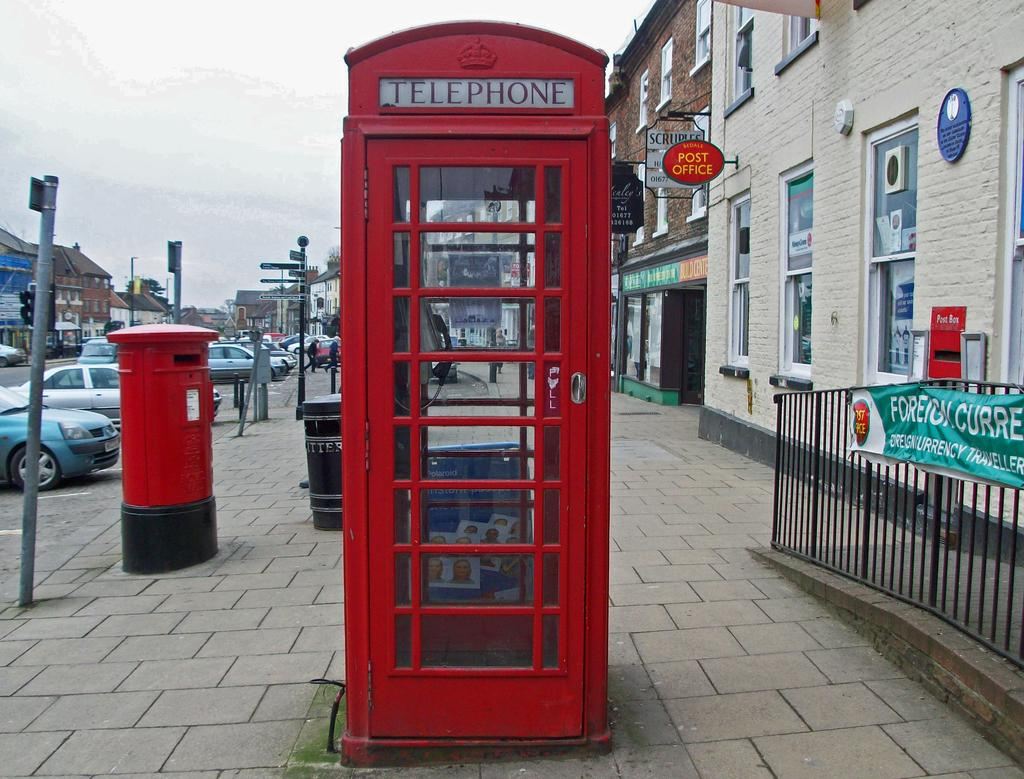Provide a one-sentence caption for the provided image. A large red phone booth like the one from Doctor Who that says Telephone. 